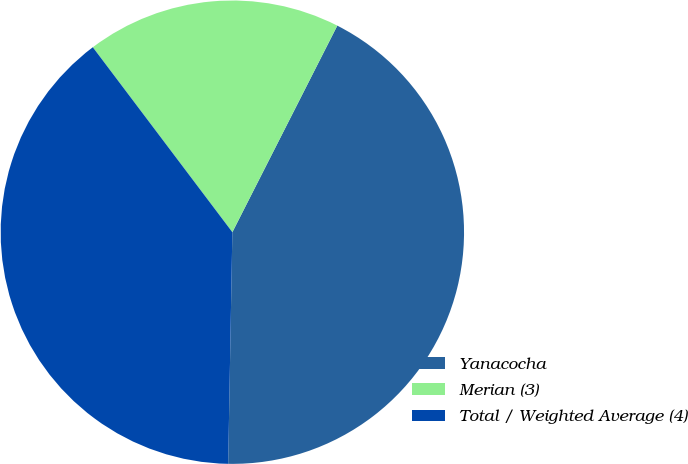Convert chart to OTSL. <chart><loc_0><loc_0><loc_500><loc_500><pie_chart><fcel>Yanacocha<fcel>Merian (3)<fcel>Total / Weighted Average (4)<nl><fcel>42.81%<fcel>17.77%<fcel>39.43%<nl></chart> 